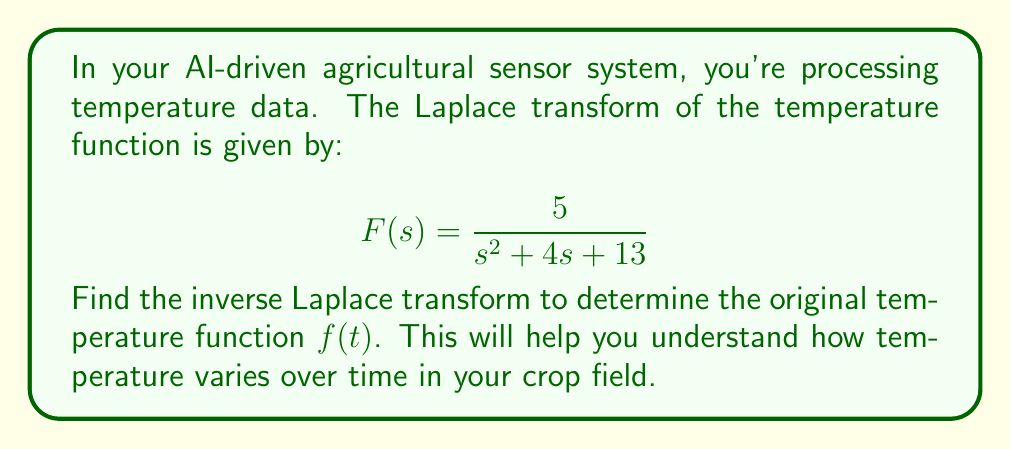Provide a solution to this math problem. To find the inverse Laplace transform, we'll follow these steps:

1) First, we need to recognize that this is in the form of:

   $$\frac{A}{s^2 + 2as + b^2}$$

   where $A = 5$, $2a = 4$ (so $a = 2$), and $b^2 = 13$.

2) The inverse Laplace transform of this form is:

   $$\mathcal{L}^{-1}\left\{\frac{A}{s^2 + 2as + b^2}\right\} = \frac{A}{\sqrt{b^2 - a^2}}e^{-at}\sin(\sqrt{b^2 - a^2}t)$$

3) We need to calculate $\sqrt{b^2 - a^2}$:
   
   $b^2 = 13$, so $b = \sqrt{13}$
   $a^2 = 2^2 = 4$
   
   $\sqrt{b^2 - a^2} = \sqrt{13 - 4} = \sqrt{9} = 3$

4) Now we can substitute our values:

   $A = 5$
   $a = 2$
   $\sqrt{b^2 - a^2} = 3$

5) Plugging these into our formula:

   $$f(t) = \frac{5}{3}e^{-2t}\sin(3t)$$

This is our final answer, representing the temperature function over time.
Answer: $$f(t) = \frac{5}{3}e^{-2t}\sin(3t)$$ 